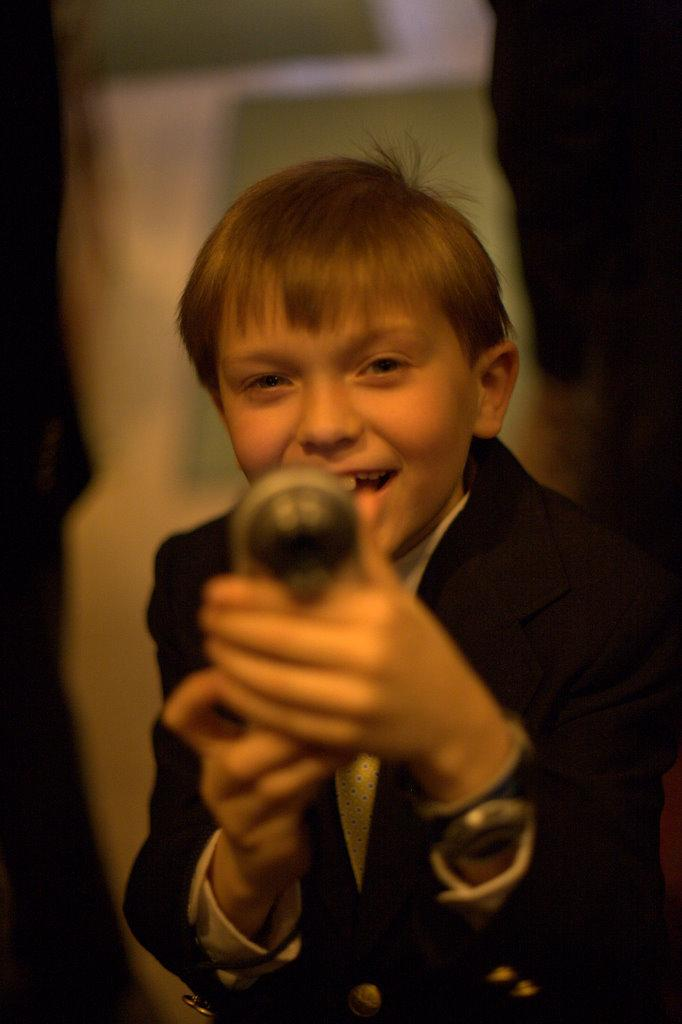Who is the main subject in the image? There is a boy in the image. What is the boy wearing? The boy is wearing a black suit. What is the boy holding in the image? The boy is holding a toy. Can you describe the background of the image? The background of the image is blurry. Is the boy taking a bath in the image? No, there is no indication that the boy is taking a bath in the image. What type of bun is the boy eating in the image? There is no bun present in the image; the boy is holding a toy. 